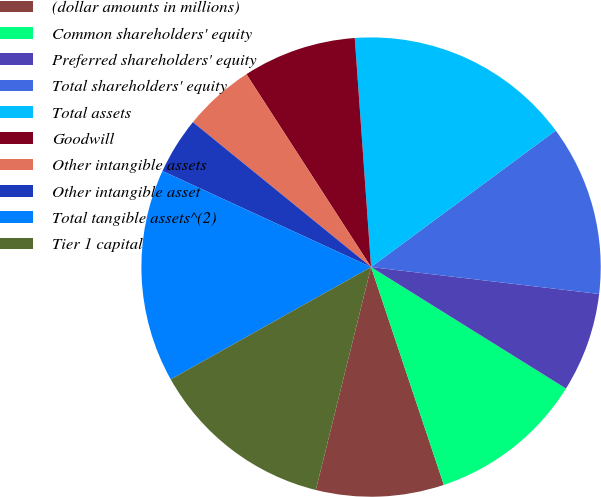Convert chart. <chart><loc_0><loc_0><loc_500><loc_500><pie_chart><fcel>(dollar amounts in millions)<fcel>Common shareholders' equity<fcel>Preferred shareholders' equity<fcel>Total shareholders' equity<fcel>Total assets<fcel>Goodwill<fcel>Other intangible assets<fcel>Other intangible asset<fcel>Total tangible assets^(2)<fcel>Tier 1 capital<nl><fcel>9.0%<fcel>11.0%<fcel>7.0%<fcel>12.0%<fcel>16.0%<fcel>8.0%<fcel>5.0%<fcel>4.0%<fcel>15.0%<fcel>13.0%<nl></chart> 